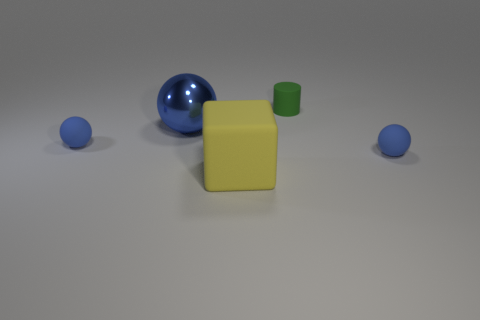Are there any big yellow cubes that are to the right of the matte sphere to the right of the blue metal object?
Your answer should be very brief. No. What is the large ball made of?
Provide a short and direct response. Metal. Are there any blue objects behind the tiny green matte thing?
Provide a succinct answer. No. Is the number of rubber balls to the right of the big rubber thing the same as the number of large blue shiny things that are in front of the large metal sphere?
Keep it short and to the point. No. How many big blue balls are there?
Make the answer very short. 1. Are there more balls that are to the left of the large shiny ball than metallic spheres?
Give a very brief answer. No. There is a tiny blue ball that is left of the matte cube; what is its material?
Offer a very short reply. Rubber. How many rubber cylinders have the same color as the large ball?
Make the answer very short. 0. Does the blue object that is to the right of the small matte cylinder have the same size as the matte ball to the left of the small rubber cylinder?
Your response must be concise. Yes. Do the block and the sphere that is right of the large rubber object have the same size?
Your answer should be compact. No. 